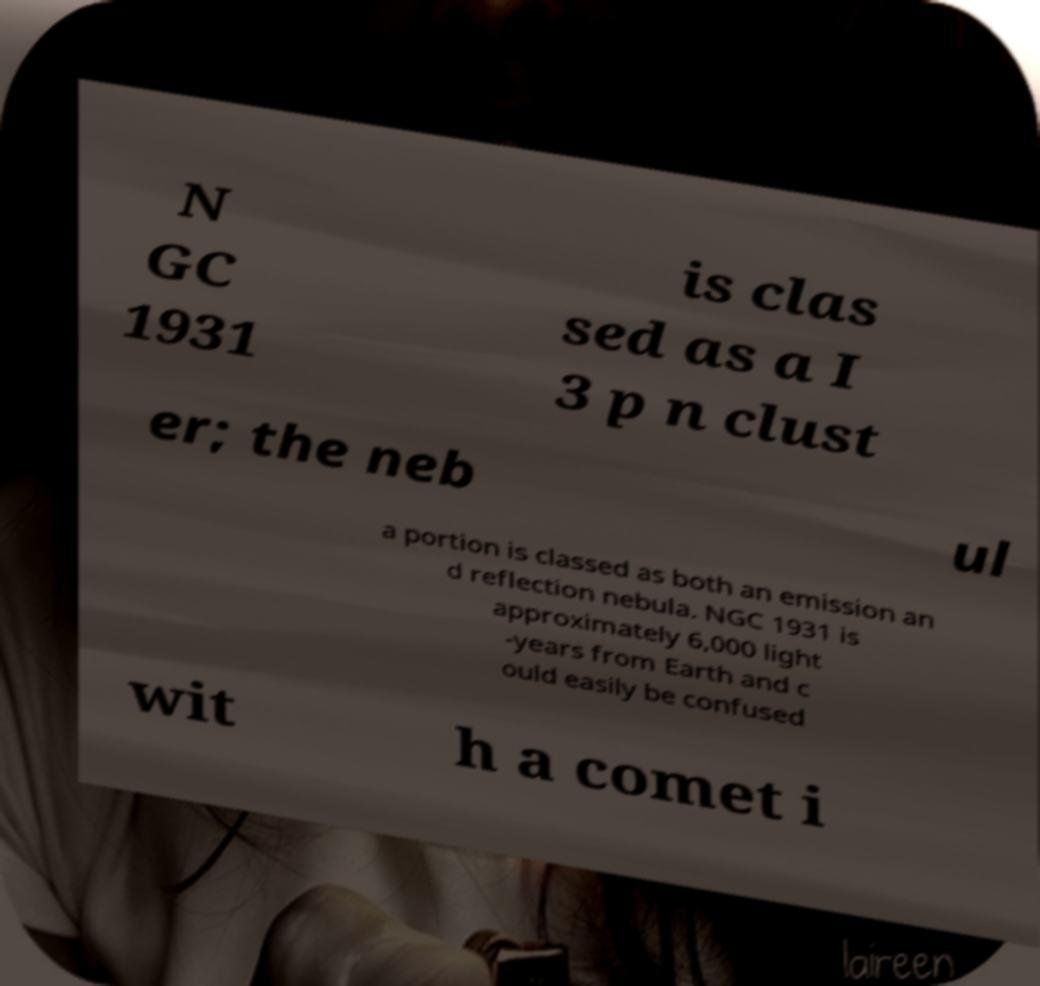Please identify and transcribe the text found in this image. N GC 1931 is clas sed as a I 3 p n clust er; the neb ul a portion is classed as both an emission an d reflection nebula. NGC 1931 is approximately 6,000 light -years from Earth and c ould easily be confused wit h a comet i 